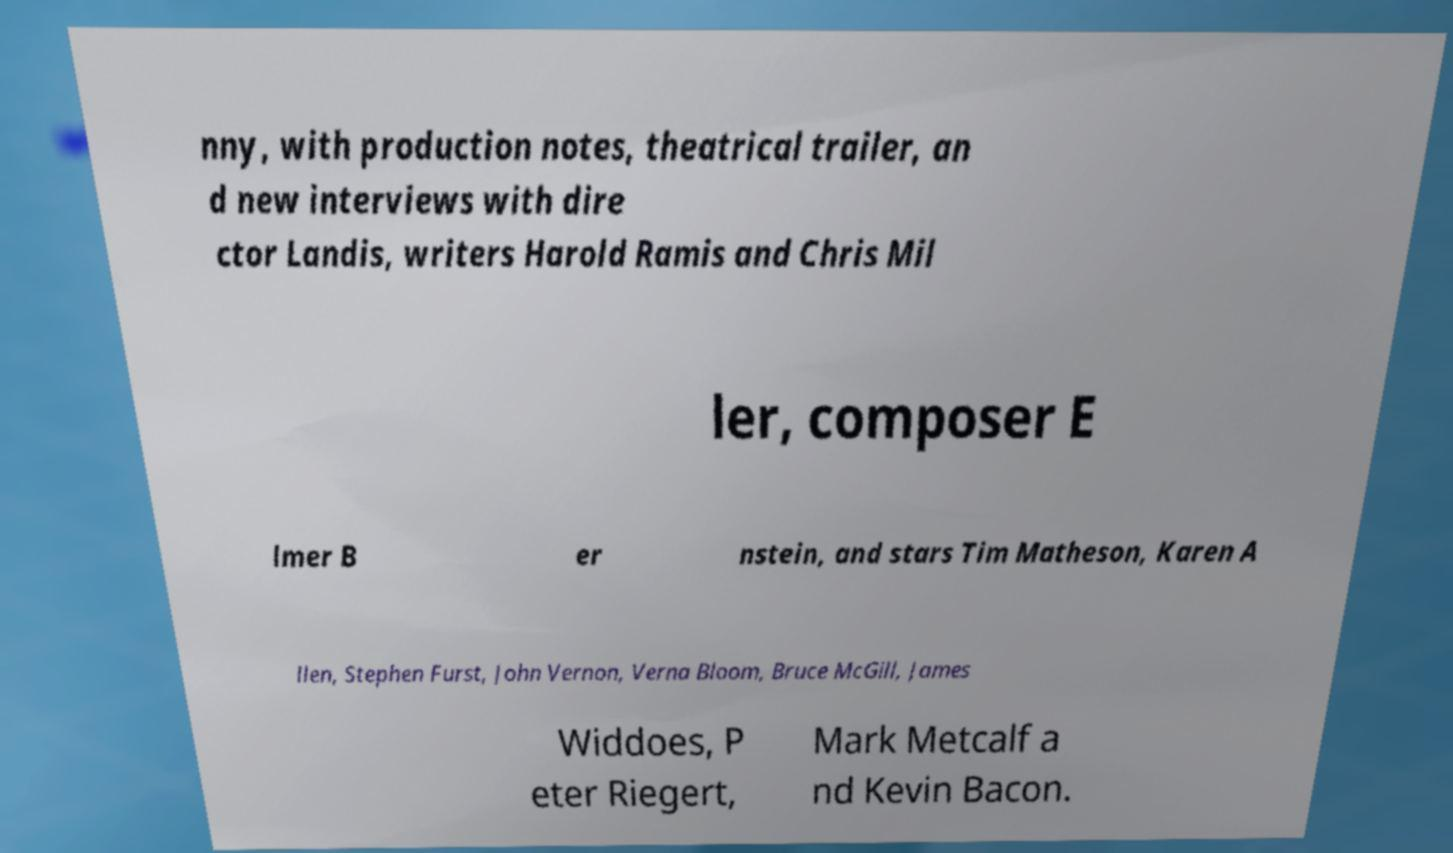There's text embedded in this image that I need extracted. Can you transcribe it verbatim? nny, with production notes, theatrical trailer, an d new interviews with dire ctor Landis, writers Harold Ramis and Chris Mil ler, composer E lmer B er nstein, and stars Tim Matheson, Karen A llen, Stephen Furst, John Vernon, Verna Bloom, Bruce McGill, James Widdoes, P eter Riegert, Mark Metcalf a nd Kevin Bacon. 